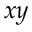<formula> <loc_0><loc_0><loc_500><loc_500>x y</formula> 